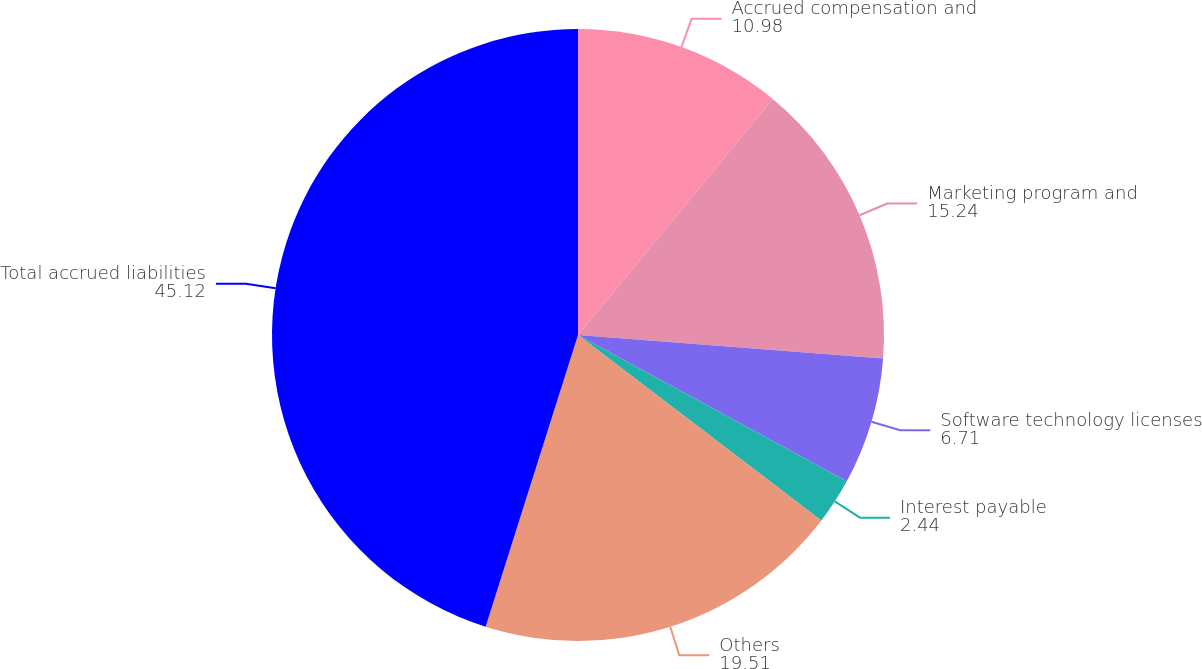<chart> <loc_0><loc_0><loc_500><loc_500><pie_chart><fcel>Accrued compensation and<fcel>Marketing program and<fcel>Software technology licenses<fcel>Interest payable<fcel>Others<fcel>Total accrued liabilities<nl><fcel>10.98%<fcel>15.24%<fcel>6.71%<fcel>2.44%<fcel>19.51%<fcel>45.12%<nl></chart> 